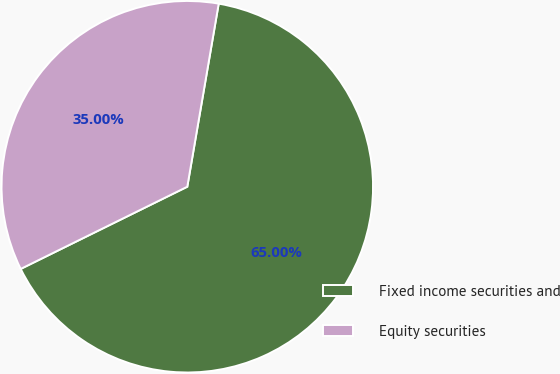Convert chart. <chart><loc_0><loc_0><loc_500><loc_500><pie_chart><fcel>Fixed income securities and<fcel>Equity securities<nl><fcel>65.0%<fcel>35.0%<nl></chart> 